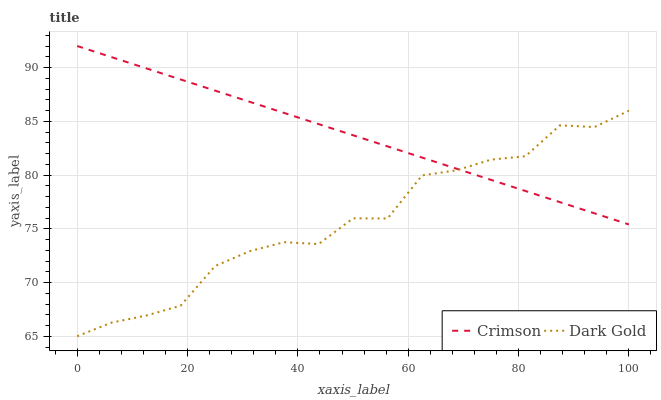Does Dark Gold have the minimum area under the curve?
Answer yes or no. Yes. Does Crimson have the maximum area under the curve?
Answer yes or no. Yes. Does Dark Gold have the maximum area under the curve?
Answer yes or no. No. Is Crimson the smoothest?
Answer yes or no. Yes. Is Dark Gold the roughest?
Answer yes or no. Yes. Is Dark Gold the smoothest?
Answer yes or no. No. Does Dark Gold have the lowest value?
Answer yes or no. Yes. Does Crimson have the highest value?
Answer yes or no. Yes. Does Dark Gold have the highest value?
Answer yes or no. No. Does Crimson intersect Dark Gold?
Answer yes or no. Yes. Is Crimson less than Dark Gold?
Answer yes or no. No. Is Crimson greater than Dark Gold?
Answer yes or no. No. 